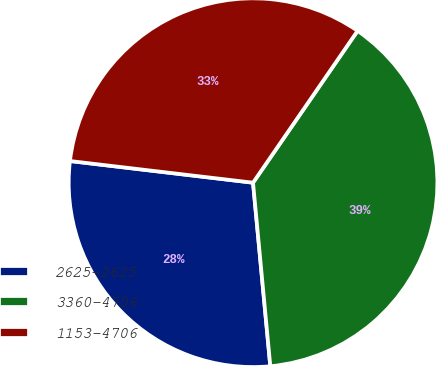<chart> <loc_0><loc_0><loc_500><loc_500><pie_chart><fcel>2625-2625<fcel>3360-4706<fcel>1153-4706<nl><fcel>28.37%<fcel>38.91%<fcel>32.72%<nl></chart> 